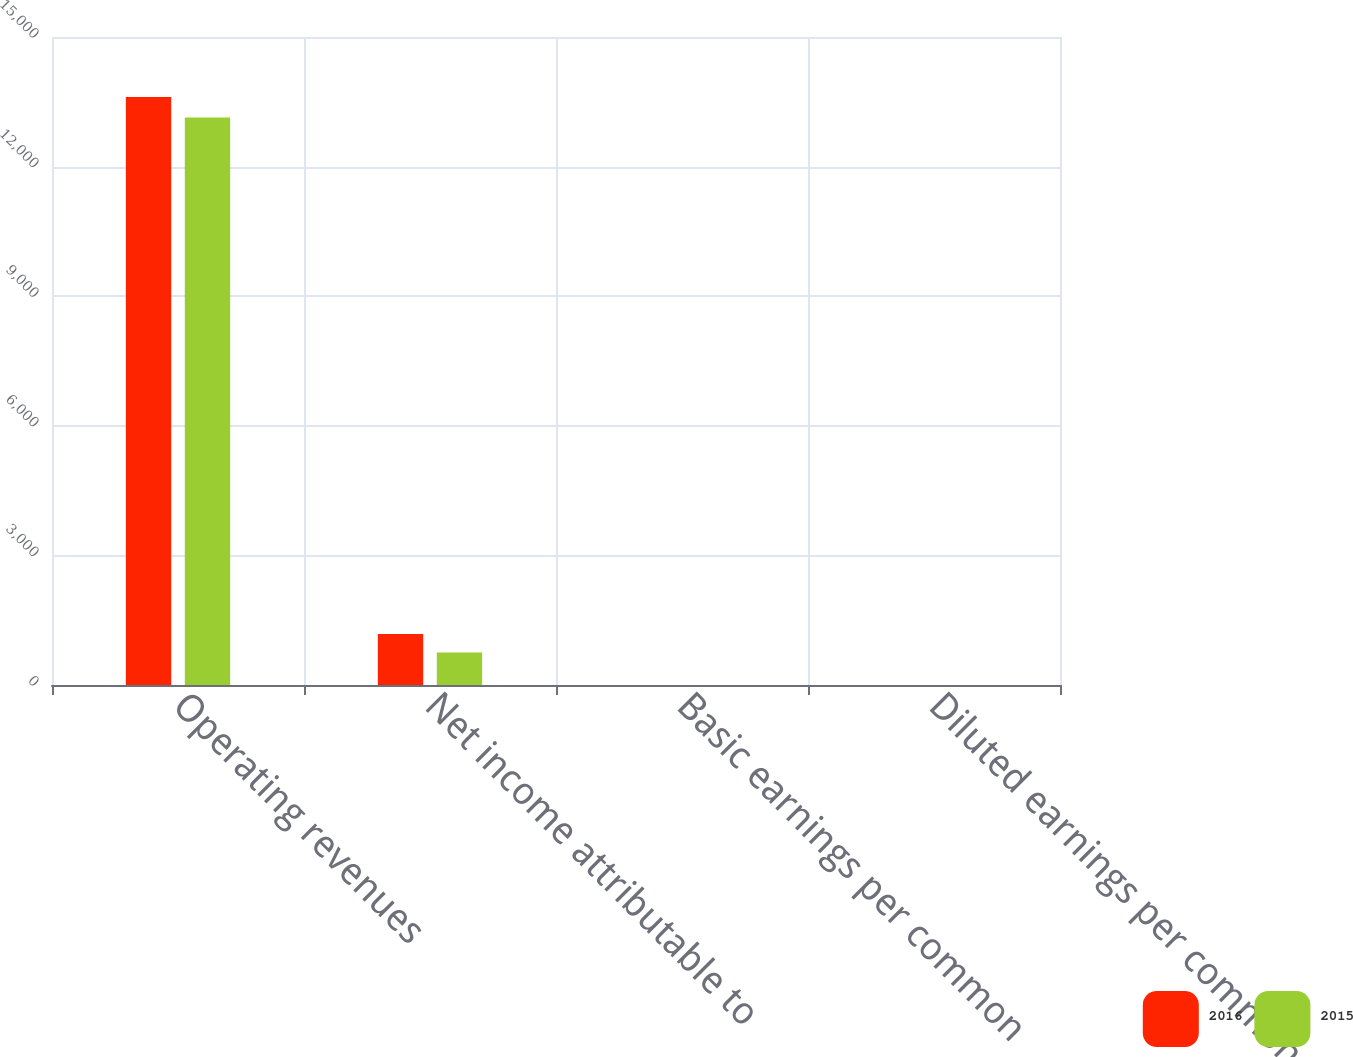Convert chart to OTSL. <chart><loc_0><loc_0><loc_500><loc_500><stacked_bar_chart><ecel><fcel>Operating revenues<fcel>Net income attributable to<fcel>Basic earnings per common<fcel>Diluted earnings per common<nl><fcel>2016<fcel>13611<fcel>1182<fcel>2.67<fcel>2.65<nl><fcel>2015<fcel>13137<fcel>751<fcel>1.66<fcel>1.65<nl></chart> 